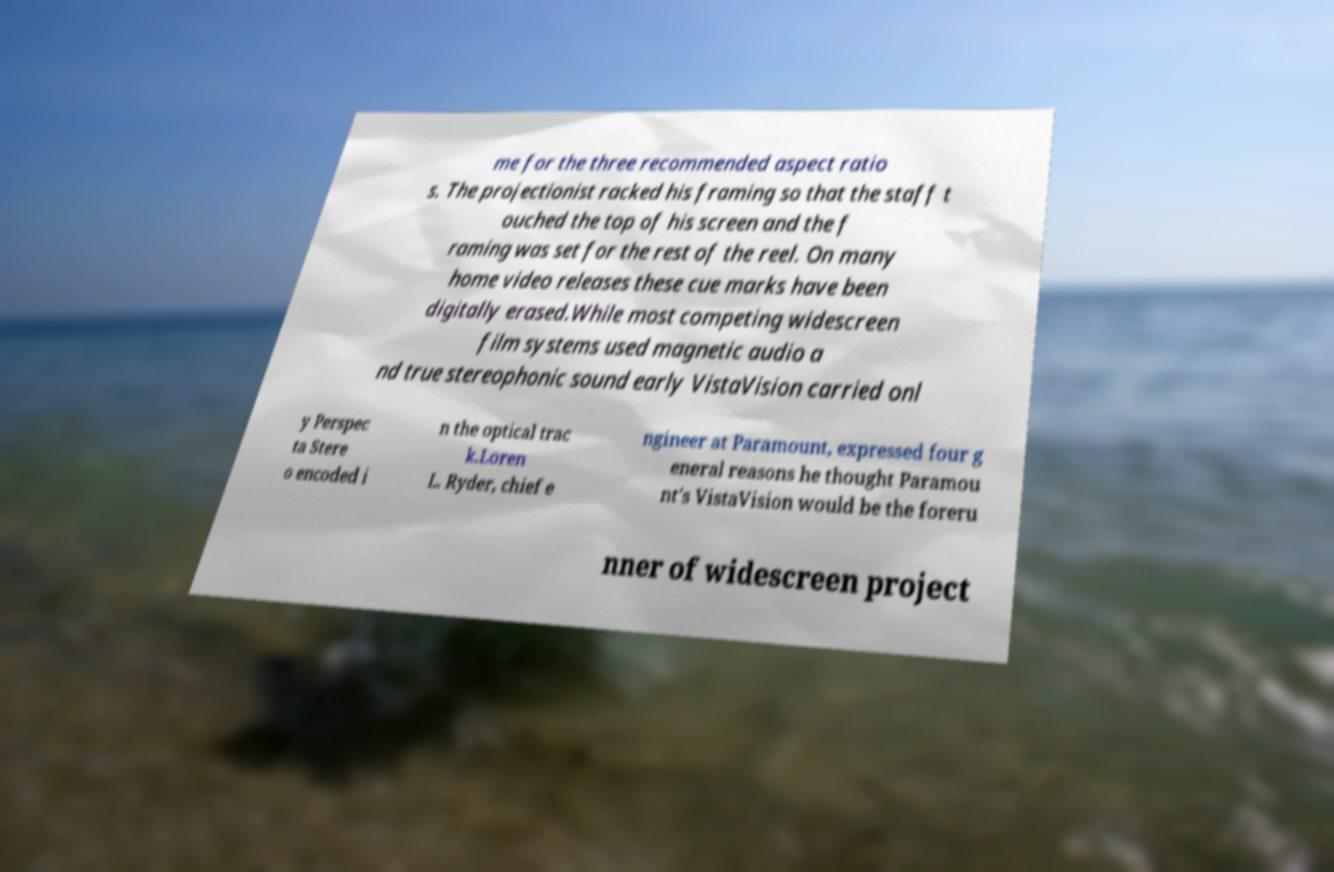Please identify and transcribe the text found in this image. me for the three recommended aspect ratio s. The projectionist racked his framing so that the staff t ouched the top of his screen and the f raming was set for the rest of the reel. On many home video releases these cue marks have been digitally erased.While most competing widescreen film systems used magnetic audio a nd true stereophonic sound early VistaVision carried onl y Perspec ta Stere o encoded i n the optical trac k.Loren L. Ryder, chief e ngineer at Paramount, expressed four g eneral reasons he thought Paramou nt's VistaVision would be the foreru nner of widescreen project 